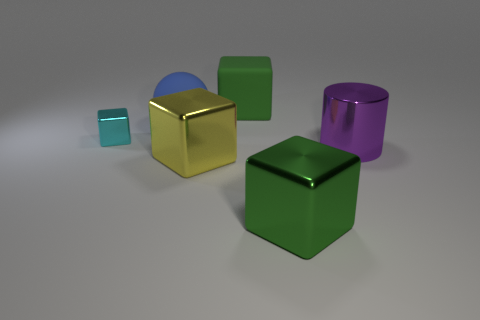What could be the context or setting of this image? This image may represent a simple 3D modeling scene, typically used for rendering tests. The variety of shapes and materials could be showcasing the rendering capabilities of a graphics engine, illustrating how different textures and lighting conditions interact with these basic geometric forms. 